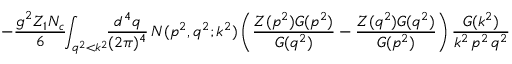<formula> <loc_0><loc_0><loc_500><loc_500>- \frac { g ^ { 2 } Z _ { 1 } N _ { c } } { 6 } \, \int _ { q ^ { 2 } < k ^ { 2 } } \, \frac { d ^ { 4 } q } { ( 2 \pi ) ^ { 4 } } \, N ( p ^ { 2 } , q ^ { 2 } ; k ^ { 2 } ) \left ( \frac { Z ( p ^ { 2 } ) G ( p ^ { 2 } ) } { G ( q ^ { 2 } ) } - \frac { Z ( q ^ { 2 } ) G ( q ^ { 2 } ) } { G ( p ^ { 2 } ) } \right ) \frac { G ( k ^ { 2 } ) } { k ^ { 2 } \, p ^ { 2 } \, q ^ { 2 } }</formula> 